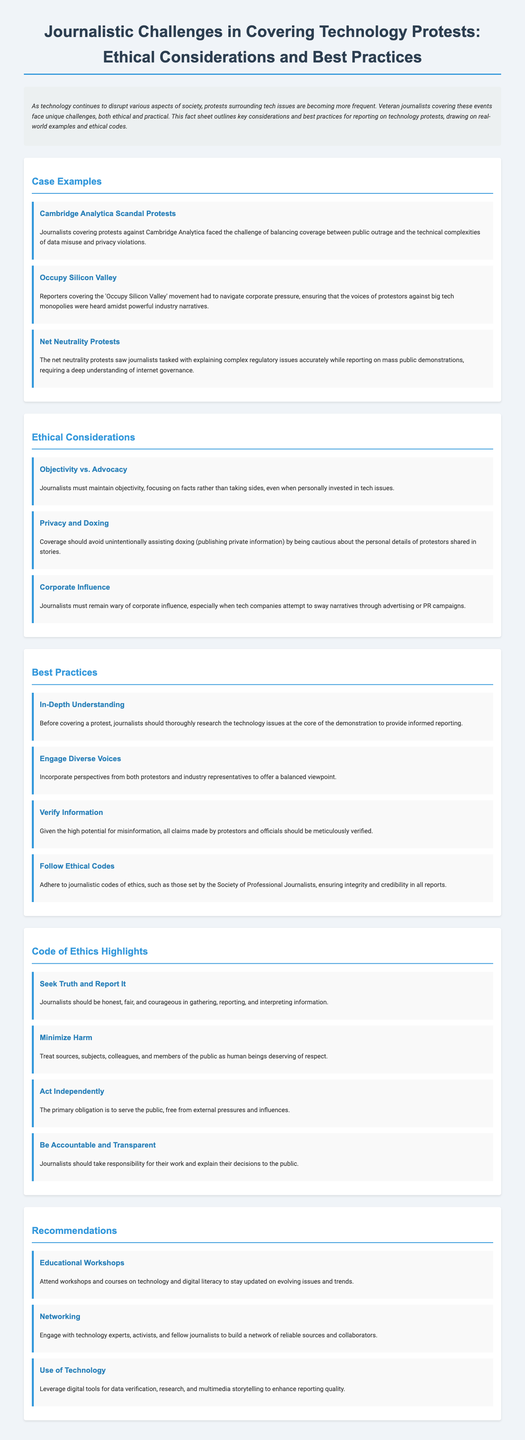what is the title of the document? The title provides the main topic covered in the fact sheet, which is focused on journalistic challenges related to technology protests.
Answer: Journalistic Challenges in Covering Technology Protests: Ethical Considerations and Best Practices how many case examples are provided? The document lists specific case examples that illustrate journalistic challenges, which can be counted in the relevant section.
Answer: 3 what ethical consideration addresses the danger of personal information exposure? This is identified as a specific challenge faced by journalists working with protester information.
Answer: Privacy and Doxing name one best practice recommended for journalists covering technology protests. The document outlines specific best practices for reporters to enhance their coverage of technology protests.
Answer: In-Depth Understanding what is one highlight from the Code of Ethics mentioned? The document lists key principles that journalists should follow, with one of them directly related to the integrity of reporting.
Answer: Seek Truth and Report It which protest is associated with the issue of net neutrality? The case example specifically connects the protest to its respective technological concern.
Answer: Net Neutrality Protests what is one recommendation given to journalists in the document? The document provides actionable suggestions aimed at improving journalistic practices while covering technology protests.
Answer: Educational Workshops 